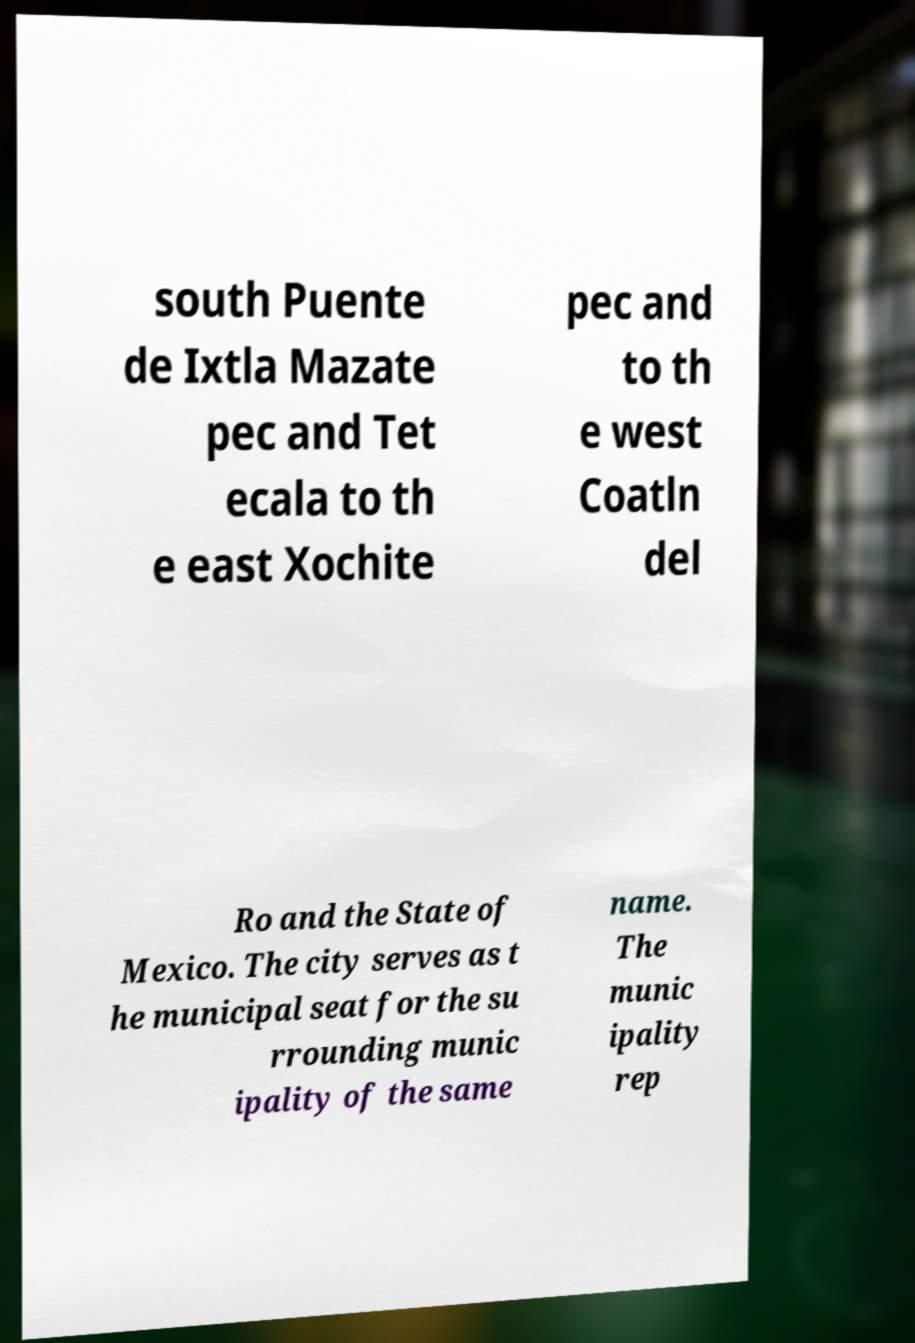Please identify and transcribe the text found in this image. south Puente de Ixtla Mazate pec and Tet ecala to th e east Xochite pec and to th e west Coatln del Ro and the State of Mexico. The city serves as t he municipal seat for the su rrounding munic ipality of the same name. The munic ipality rep 